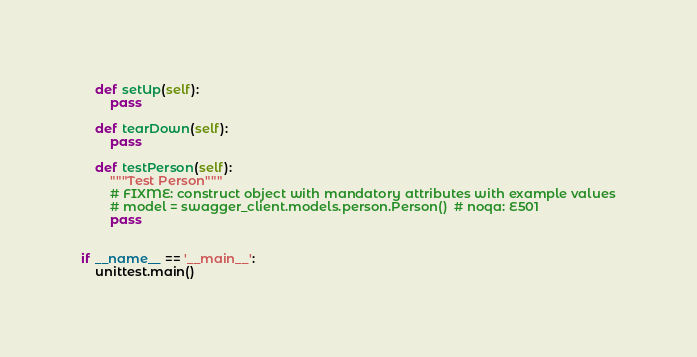Convert code to text. <code><loc_0><loc_0><loc_500><loc_500><_Python_>    def setUp(self):
        pass

    def tearDown(self):
        pass

    def testPerson(self):
        """Test Person"""
        # FIXME: construct object with mandatory attributes with example values
        # model = swagger_client.models.person.Person()  # noqa: E501
        pass


if __name__ == '__main__':
    unittest.main()
</code> 